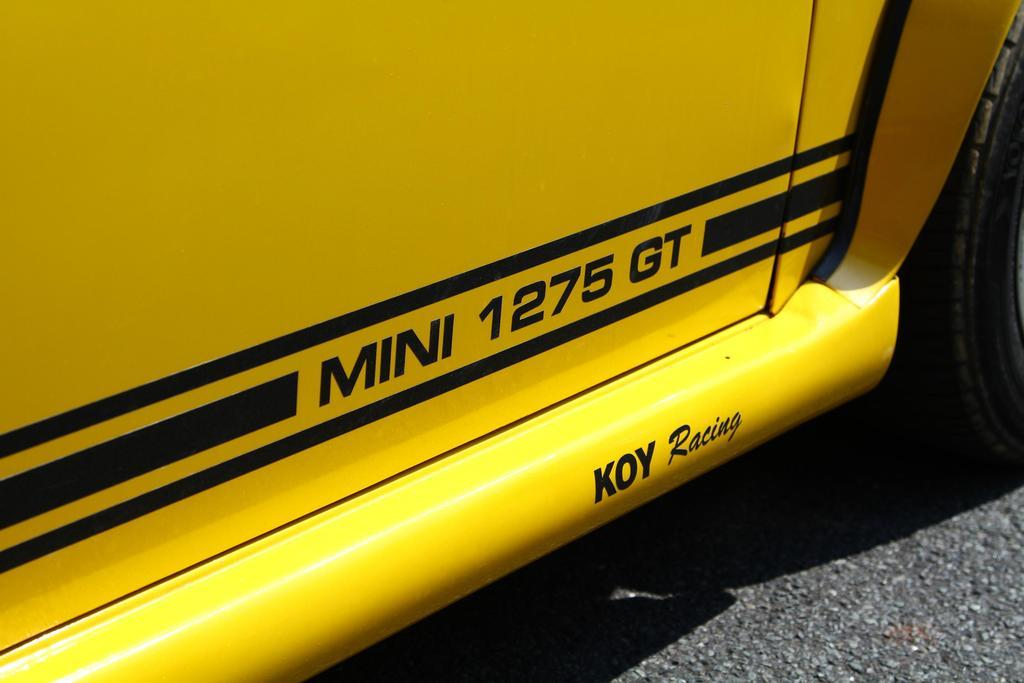What color is the vehicle in the picture? The vehicle in the picture is yellow. What can be found in the center of the picture? There is text in the center of the picture. What object is on the right side of the picture? There is a tire on the right side of the picture. What surface is visible at the bottom of the picture? There is a road at the bottom of the picture. Where is the daughter sitting at the desk in the picture? There is no daughter or desk present in the picture. What type of jewel is featured in the center of the picture? There is no jewel present in the picture; there is only text in the center. 